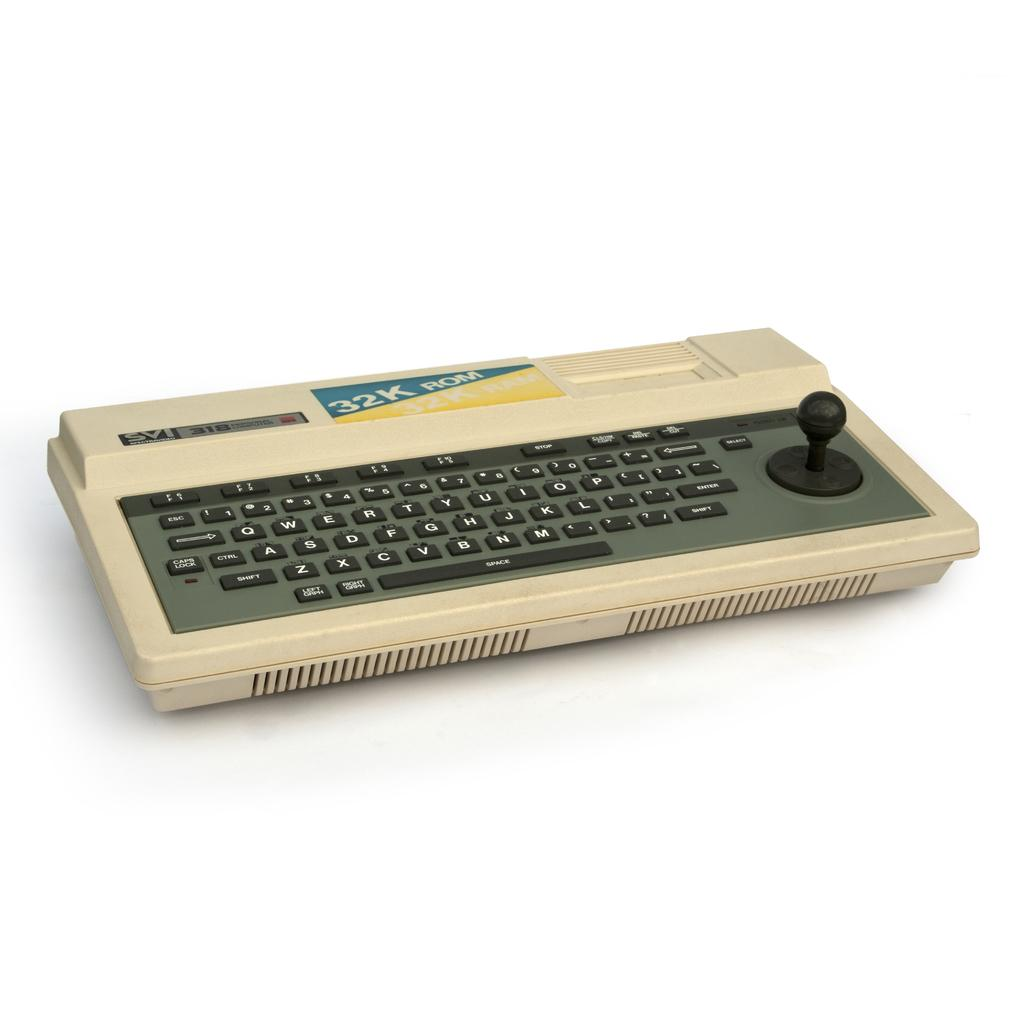<image>
Share a concise interpretation of the image provided. A white keyboard with the letters and word written on the top 32K Rom 